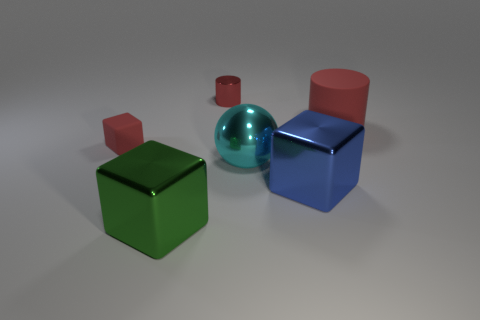There is a red object that is on the left side of the big cylinder and right of the green object; what shape is it?
Your answer should be very brief. Cylinder. What is the shape of the small red object to the left of the large green cube that is in front of the big cyan metallic thing?
Offer a terse response. Cube. Does the blue shiny thing have the same shape as the large green thing?
Provide a short and direct response. Yes. There is a small cylinder that is the same color as the big matte thing; what material is it?
Your response must be concise. Metal. Do the small block and the small shiny object have the same color?
Offer a terse response. Yes. There is a rubber object that is to the right of the rubber cube that is behind the ball; what number of balls are right of it?
Ensure brevity in your answer.  0. There is a red object that is made of the same material as the blue block; what is its shape?
Offer a very short reply. Cylinder. The tiny thing that is in front of the red cylinder to the right of the small red thing behind the small red block is made of what material?
Make the answer very short. Rubber. What number of things are big things that are to the left of the big blue object or purple metallic balls?
Give a very brief answer. 2. What number of other objects are the same shape as the big blue metallic thing?
Offer a very short reply. 2. 